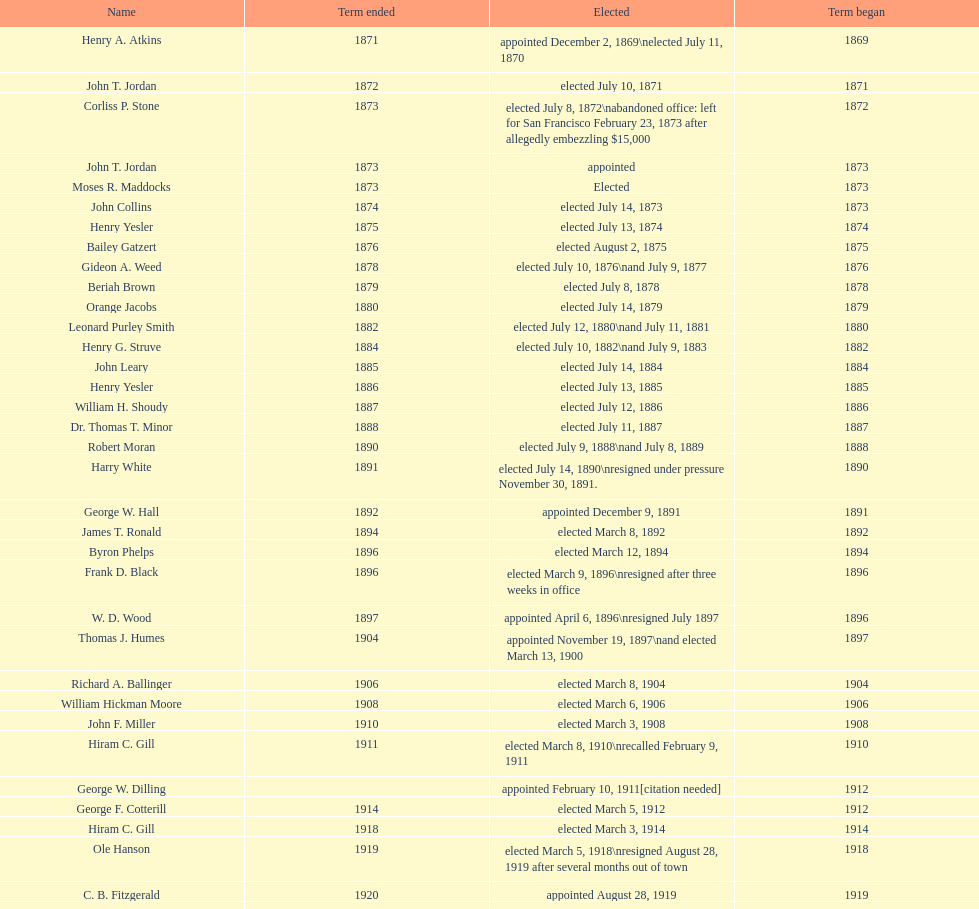Did charles royer hold office longer than paul schell? Yes. 